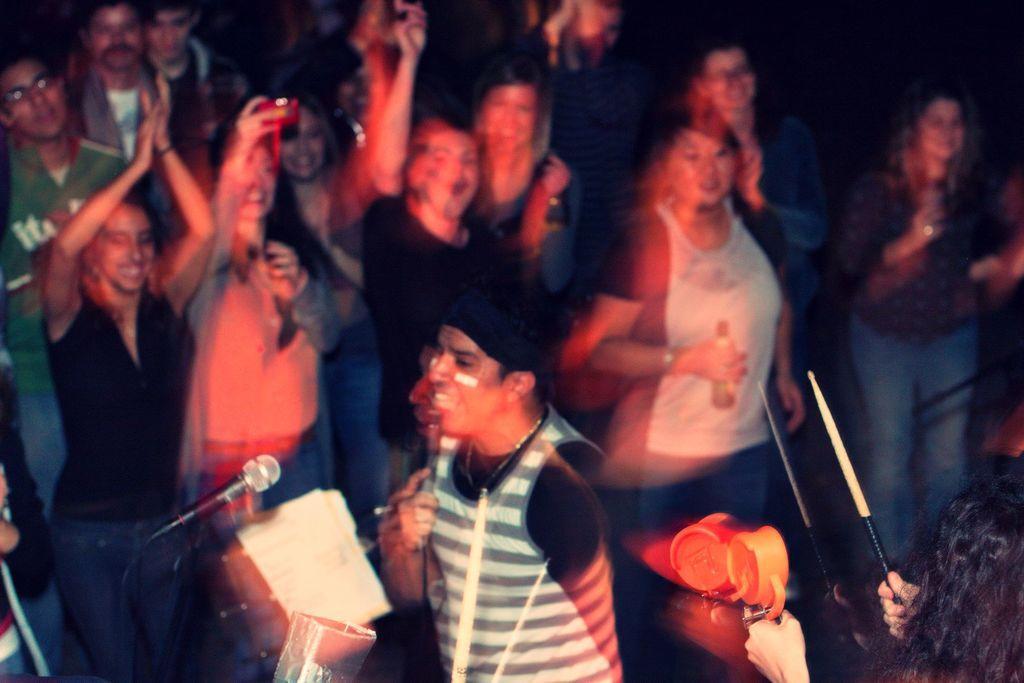How would you summarize this image in a sentence or two? In this image we can see a group of people standing. In that a person is holding a stick and an object. We can also see a mic with a stand and a person holding a camera. 